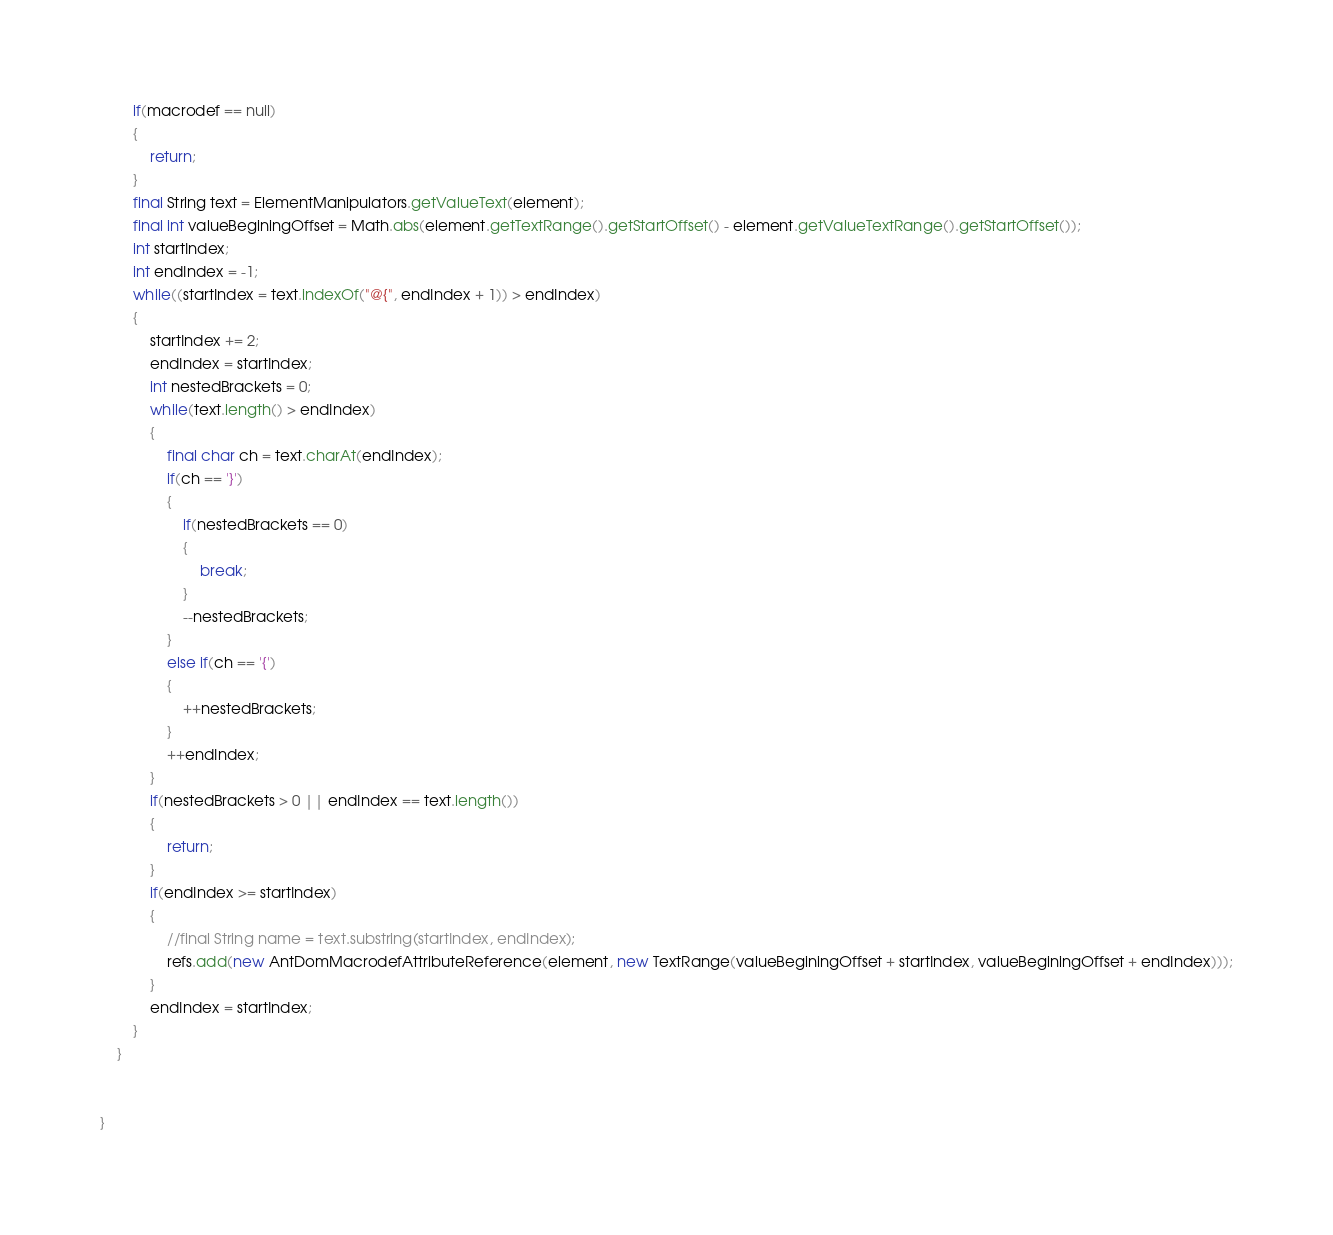Convert code to text. <code><loc_0><loc_0><loc_500><loc_500><_Java_>		if(macrodef == null)
		{
			return;
		}
		final String text = ElementManipulators.getValueText(element);
		final int valueBeginingOffset = Math.abs(element.getTextRange().getStartOffset() - element.getValueTextRange().getStartOffset());
		int startIndex;
		int endIndex = -1;
		while((startIndex = text.indexOf("@{", endIndex + 1)) > endIndex)
		{
			startIndex += 2;
			endIndex = startIndex;
			int nestedBrackets = 0;
			while(text.length() > endIndex)
			{
				final char ch = text.charAt(endIndex);
				if(ch == '}')
				{
					if(nestedBrackets == 0)
					{
						break;
					}
					--nestedBrackets;
				}
				else if(ch == '{')
				{
					++nestedBrackets;
				}
				++endIndex;
			}
			if(nestedBrackets > 0 || endIndex == text.length())
			{
				return;
			}
			if(endIndex >= startIndex)
			{
				//final String name = text.substring(startIndex, endIndex);
				refs.add(new AntDomMacrodefAttributeReference(element, new TextRange(valueBeginingOffset + startIndex, valueBeginingOffset + endIndex)));
			}
			endIndex = startIndex;
		}
	}


}
</code> 